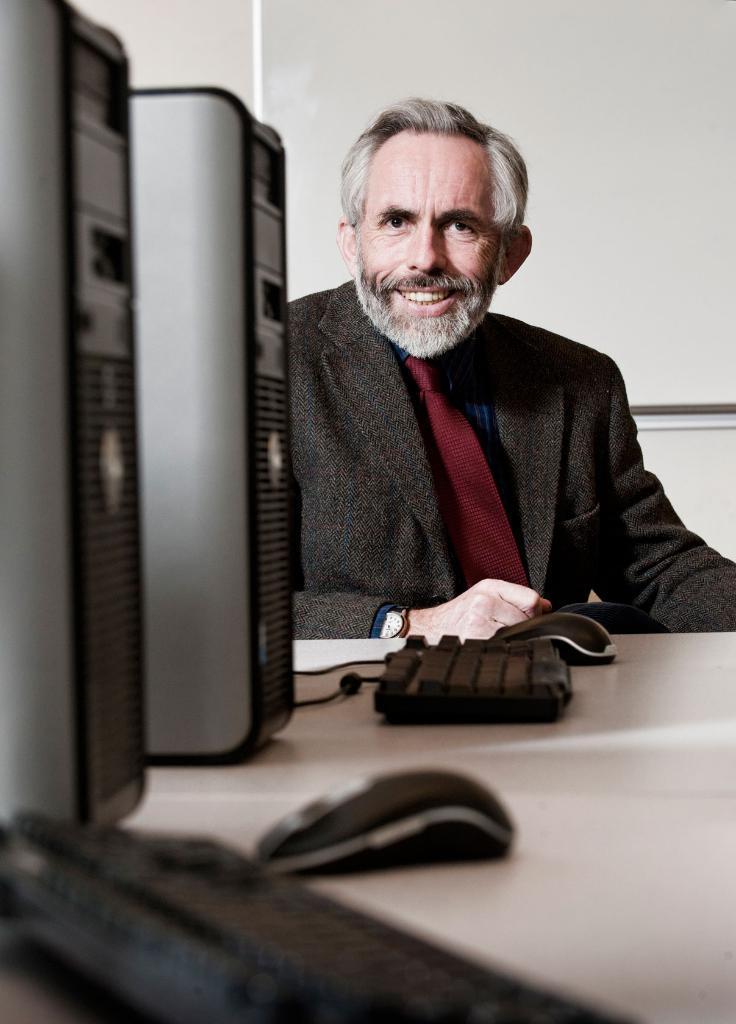How would you summarize this image in a sentence or two? In this image At the bottom there is a table on that there are two PC, two keyboards and two mouses. In the middle there is a man he wear suit and tie, watch he is smiling. 